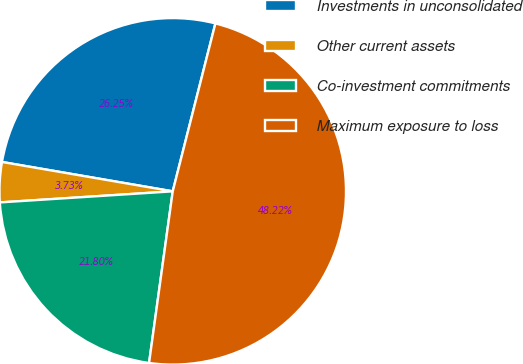Convert chart. <chart><loc_0><loc_0><loc_500><loc_500><pie_chart><fcel>Investments in unconsolidated<fcel>Other current assets<fcel>Co-investment commitments<fcel>Maximum exposure to loss<nl><fcel>26.25%<fcel>3.73%<fcel>21.8%<fcel>48.22%<nl></chart> 